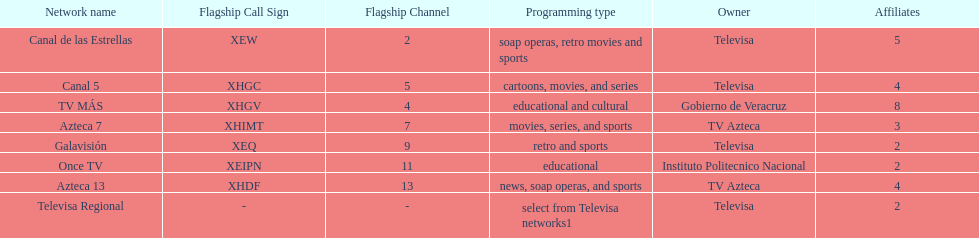Who has the most number of affiliates? TV MÁS. 